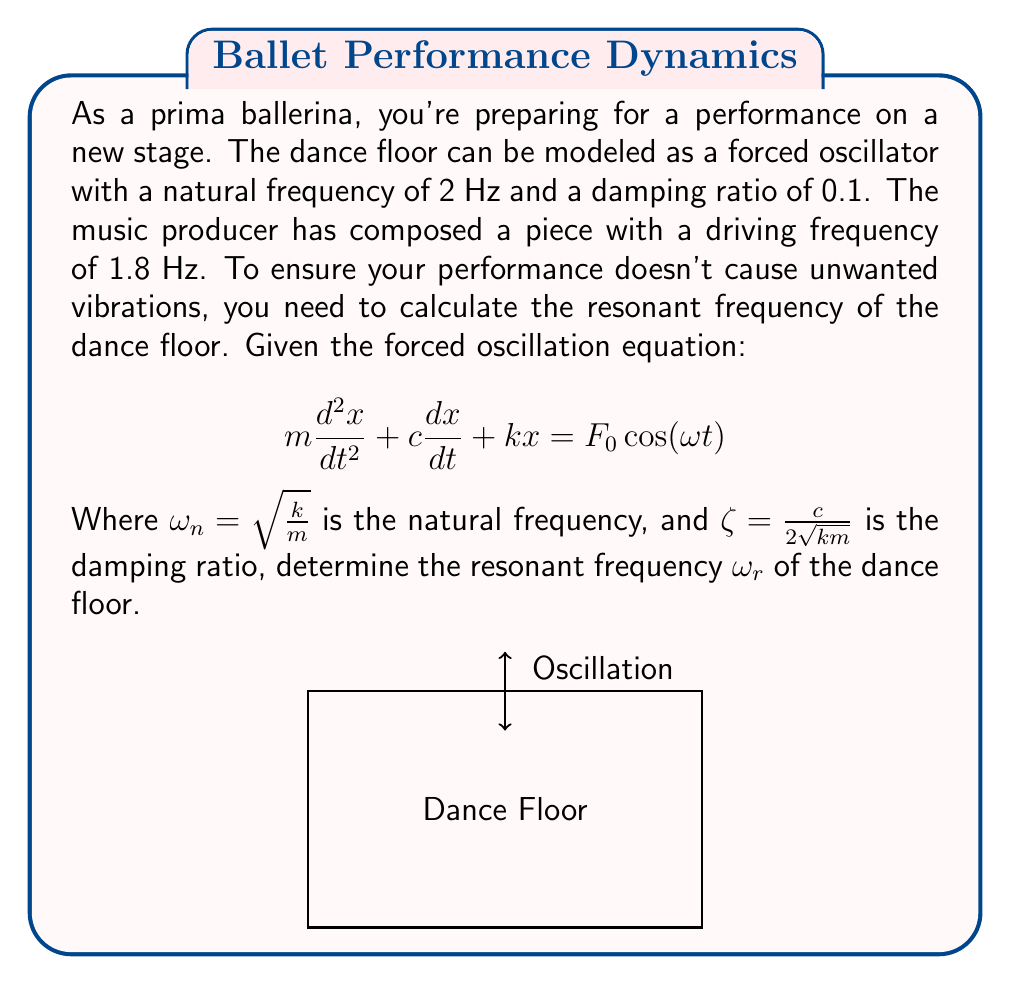Teach me how to tackle this problem. To solve this problem, we'll follow these steps:

1) The resonant frequency $\omega_r$ for a damped system is given by the equation:

   $$\omega_r = \omega_n\sqrt{1 - 2\zeta^2}$$

   Where $\omega_n$ is the natural frequency and $\zeta$ is the damping ratio.

2) We're given that the natural frequency is 2 Hz. However, we need to convert this to radians per second:

   $$\omega_n = 2 \text{ Hz} \cdot 2\pi = 4\pi \text{ rad/s}$$

3) We're also given that the damping ratio $\zeta = 0.1$.

4) Now, let's substitute these values into the resonant frequency equation:

   $$\omega_r = 4\pi\sqrt{1 - 2(0.1)^2}$$

5) Simplify inside the square root:

   $$\omega_r = 4\pi\sqrt{1 - 0.02}$$
   $$\omega_r = 4\pi\sqrt{0.98}$$

6) Calculate the final value:

   $$\omega_r \approx 12.46 \text{ rad/s}$$

7) To convert back to Hz, divide by $2\pi$:

   $$f_r = \frac{\omega_r}{2\pi} \approx 1.98 \text{ Hz}$$
Answer: 1.98 Hz 